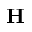<formula> <loc_0><loc_0><loc_500><loc_500>H</formula> 